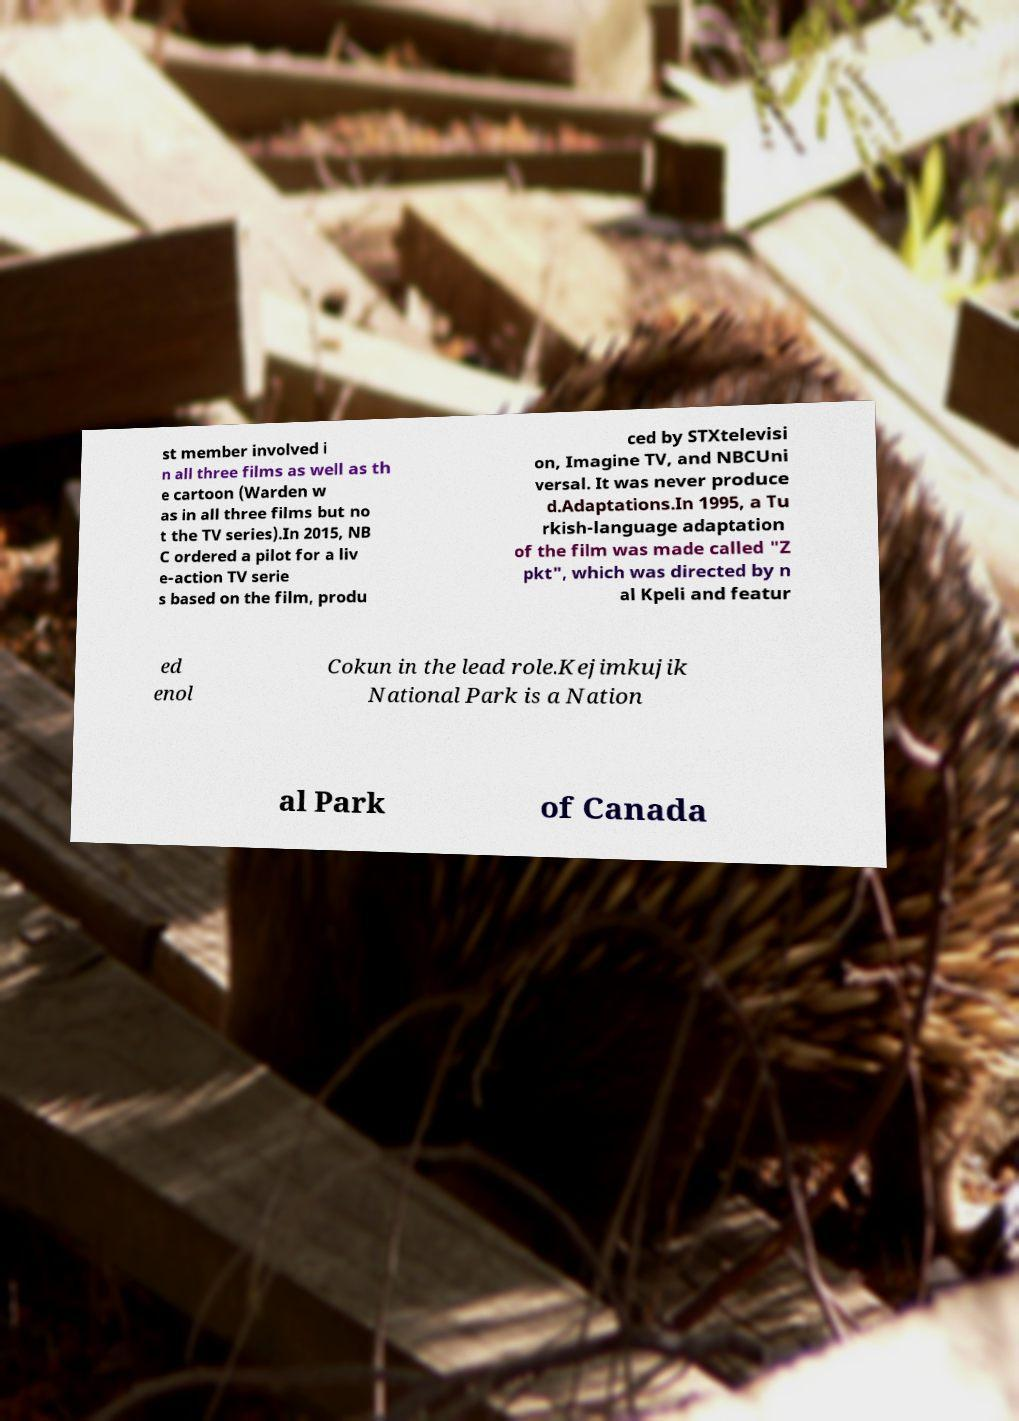Please identify and transcribe the text found in this image. st member involved i n all three films as well as th e cartoon (Warden w as in all three films but no t the TV series).In 2015, NB C ordered a pilot for a liv e-action TV serie s based on the film, produ ced by STXtelevisi on, Imagine TV, and NBCUni versal. It was never produce d.Adaptations.In 1995, a Tu rkish-language adaptation of the film was made called "Z pkt", which was directed by n al Kpeli and featur ed enol Cokun in the lead role.Kejimkujik National Park is a Nation al Park of Canada 